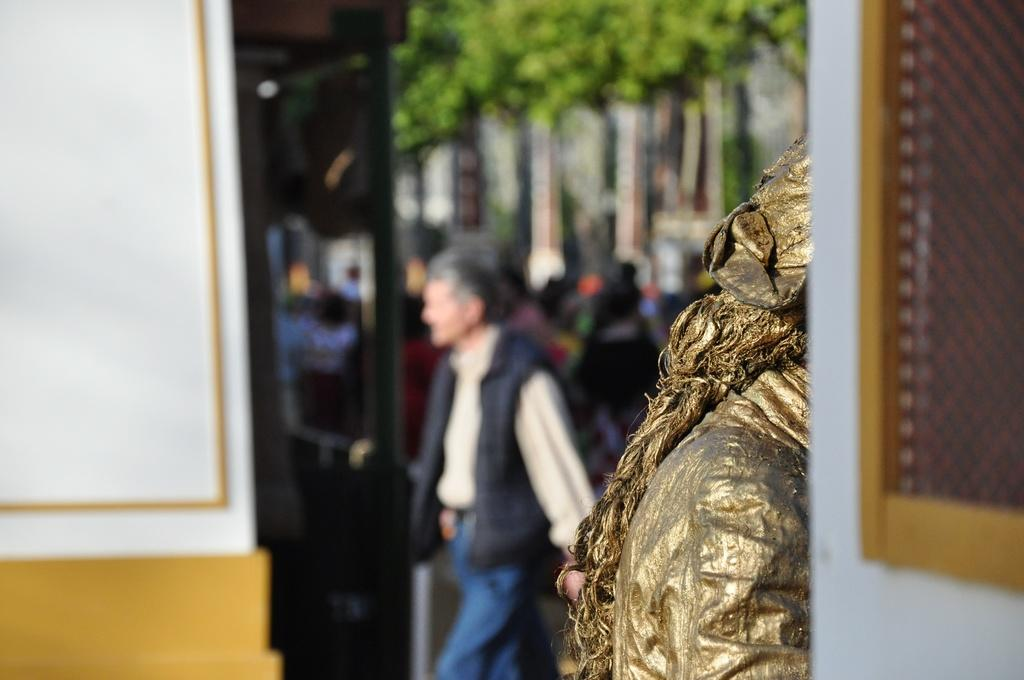Who or what is the main subject in the center of the image? There is a person in the center of the image. What can be seen on the right side of the image? There is a statue and a wall on the right side of the image. Are there any openings in the wall on the right side of the image? Yes, there is a window on the right side of the image. What else can be seen in the background of the image? There are other persons and a tree in the background of the image. What type of plastic object is being used as a riddle in the image? There is no plastic object being used as a riddle in the image. What part of the tree is visible in the image? The image does not show a specific part of the tree; it only shows the tree as a whole. 